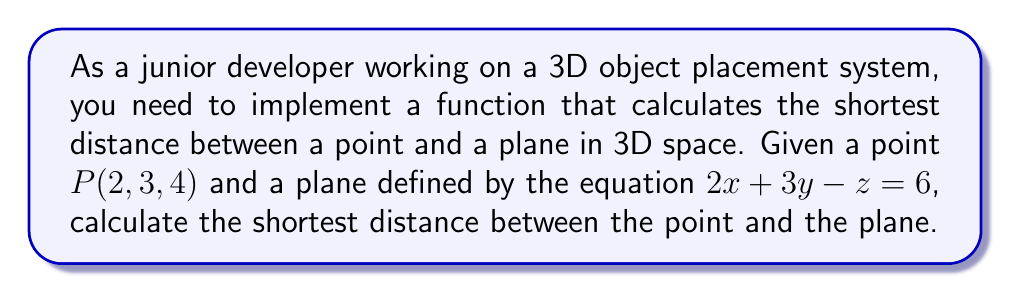What is the answer to this math problem? To solve this problem, we'll follow these steps:

1) The general equation for the shortest distance $d$ between a point $(x_0, y_0, z_0)$ and a plane $Ax + By + Cz + D = 0$ is:

   $$d = \frac{|Ax_0 + By_0 + Cz_0 + D|}{\sqrt{A^2 + B^2 + C^2}}$$

2) In our case:
   - Point $P(x_0, y_0, z_0) = (2, 3, 4)$
   - Plane equation: $2x + 3y - z = 6$, which we need to rearrange to $2x + 3y - z - 6 = 0$

   So, $A = 2$, $B = 3$, $C = -1$, and $D = -6$

3) Let's substitute these values into our distance formula:

   $$d = \frac{|2(2) + 3(3) + (-1)(4) + (-6)|}{\sqrt{2^2 + 3^2 + (-1)^2}}$$

4) Let's calculate the numerator and denominator separately:

   Numerator: $|2(2) + 3(3) + (-1)(4) + (-6)| = |4 + 9 - 4 - 6| = |3| = 3$

   Denominator: $\sqrt{2^2 + 3^2 + (-1)^2} = \sqrt{4 + 9 + 1} = \sqrt{14}$

5) Now, we can write our final answer:

   $$d = \frac{3}{\sqrt{14}}$$

This is the shortest distance between the point and the plane.
Answer: $$d = \frac{3}{\sqrt{14}}$$ 